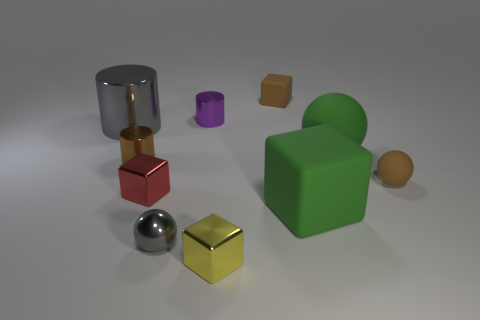Subtract all cylinders. How many objects are left? 7 Add 4 gray metallic things. How many gray metallic things are left? 6 Add 2 small blue matte cylinders. How many small blue matte cylinders exist? 2 Subtract 1 brown blocks. How many objects are left? 9 Subtract all big gray shiny blocks. Subtract all tiny gray balls. How many objects are left? 9 